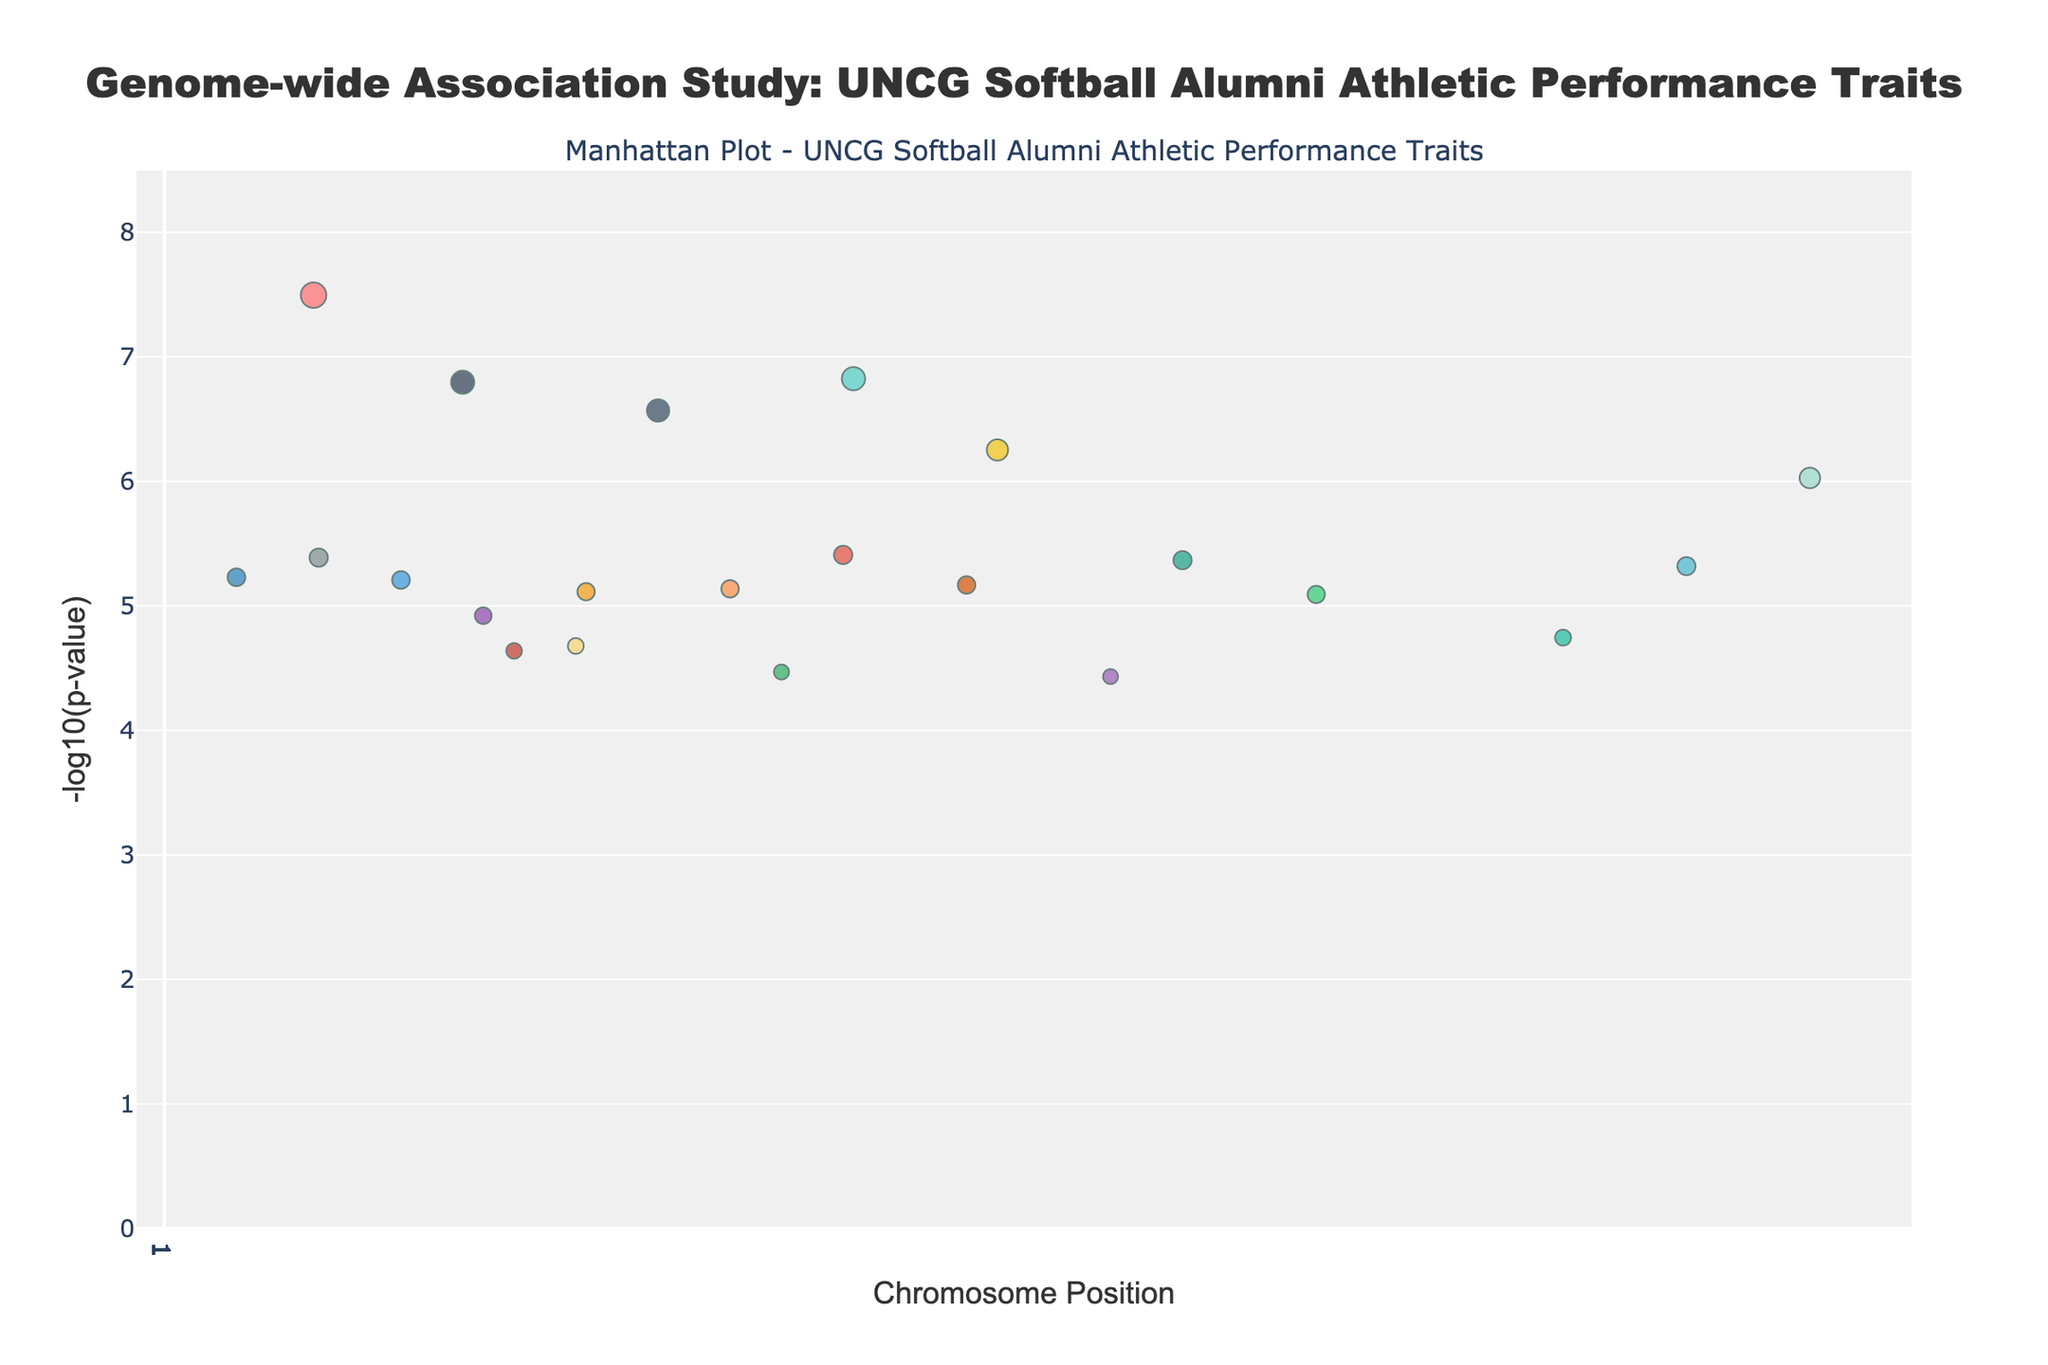What is the title of the figure? The title of the figure is located at the top and should summarize the plot's content. It reads, "Genome-wide Association Study: UNCG Softball Alumni Athletic Performance Traits."
Answer: Genome-wide Association Study: UNCG Softball Alumni Athletic Performance Traits Which gene has the smallest p-value in the study? The smallest p-value corresponds to the highest point on the y-axis. By examining the figure, we identify the gene "ACE" with the smallest p-value.
Answer: ACE How many traits are studied in this plot? Different traits are represented by various colors in the legend, each unique to a trait. Counting these unique colors should reveal the number of traits.
Answer: 22 What color represents "Muscle contraction"? The color representing "Muscle contraction" is found in the plot's legend. According to the legend, "Muscle contraction" corresponds to a yellow color.
Answer: Yellow Which chromosomes have genes with a -log10(p-value) greater than 7? Identify which chromosomes have markers above the y-axis value of 7. Chromosomes 1, 2, 13, and 22 have genes that meet this criterion.
Answer: Chromosomes 1, 2, 13, and 22 What is the p-value of the gene associated with "Muscle growth"? Locate the point on the plot associated with the trait "Muscle growth," represented by the y-axis marker. The p-value is indicated in the hover text alongside the trait. The gene for "Muscle growth" is IGF1, with a p-value of 4.3e-6.
Answer: 4.3e-6 Which trait has the highest level of significance after "Endurance"? After identifying the highest point for "Endurance," find the next highest point on the y-axis. The trait associated with the following highest point is "Power."
Answer: Power How many genes on chromosome 6 are plotted? Each chromosome's genes are plotted separately. Count the number of data points specifically for chromosome 6. There is just one gene point visible on chromosome 6.
Answer: 1 What is the range of p-values observed in this study? Determine the smallest and largest p-values indicated on the y-axis. The smallest p-value is for "ACE" (3.2e-8) and the largest can be inferred from below data points, falling around "MCT1" (3.4e-5).
Answer: 3.2e-8 to 3.4e-5 Which chromosome has the gene associated with "Lipid metabolism"? Locate the gene "APOE" linked with "Lipid metabolism." The x-axis will show the chromosome position. "Lipid metabolism" (APOE) is found on chromosome 19.
Answer: Chromosome 19 